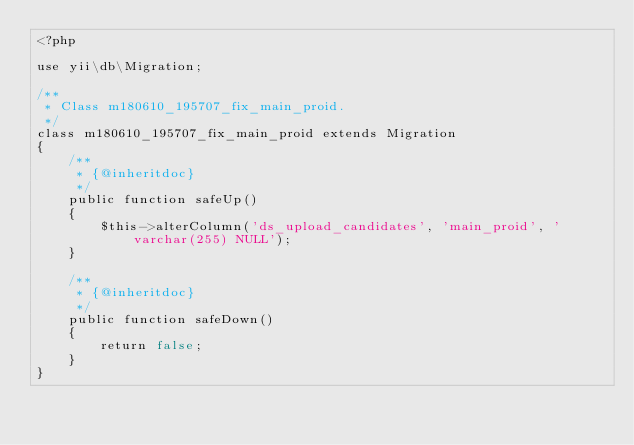<code> <loc_0><loc_0><loc_500><loc_500><_PHP_><?php

use yii\db\Migration;

/**
 * Class m180610_195707_fix_main_proid.
 */
class m180610_195707_fix_main_proid extends Migration
{
    /**
     * {@inheritdoc}
     */
    public function safeUp()
    {
        $this->alterColumn('ds_upload_candidates', 'main_proid', 'varchar(255) NULL');
    }

    /**
     * {@inheritdoc}
     */
    public function safeDown()
    {
        return false;
    }
}
</code> 